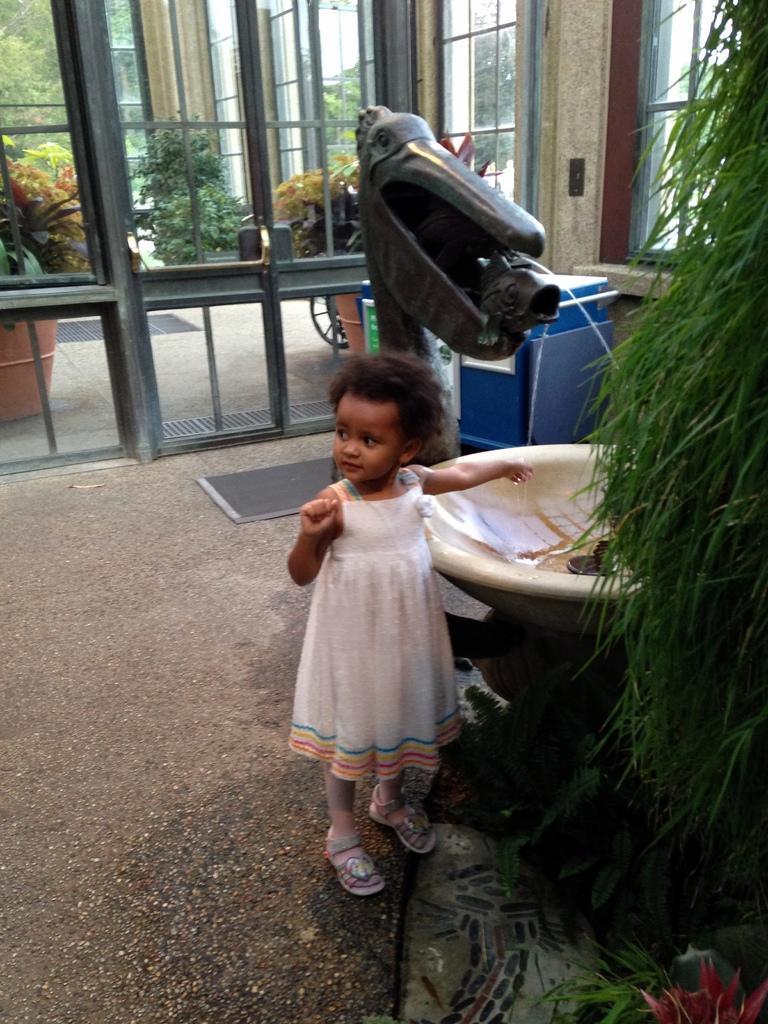In one or two sentences, can you explain what this image depicts? This image consists of a girl wearing white dress. At the bottom, there is floor. To the right, there is a plant. In the background, there are doors. 